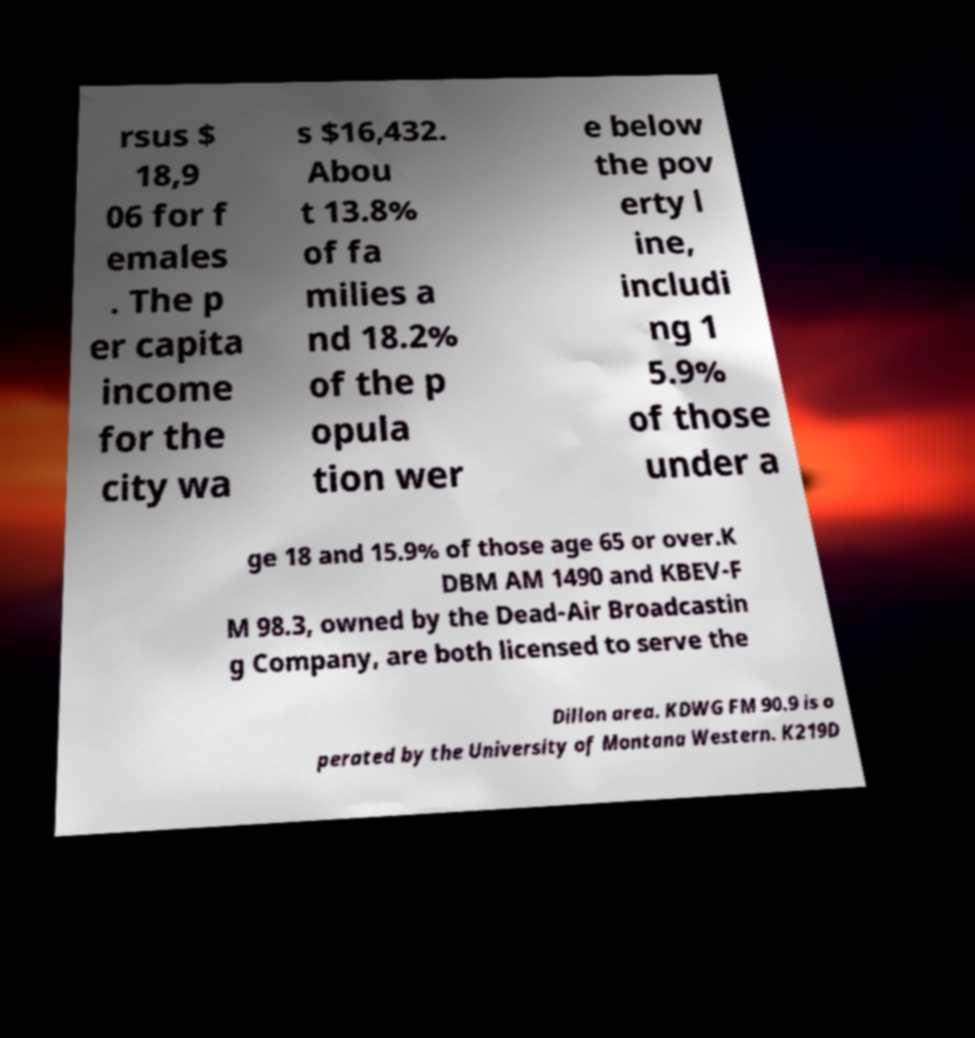Could you assist in decoding the text presented in this image and type it out clearly? rsus $ 18,9 06 for f emales . The p er capita income for the city wa s $16,432. Abou t 13.8% of fa milies a nd 18.2% of the p opula tion wer e below the pov erty l ine, includi ng 1 5.9% of those under a ge 18 and 15.9% of those age 65 or over.K DBM AM 1490 and KBEV-F M 98.3, owned by the Dead-Air Broadcastin g Company, are both licensed to serve the Dillon area. KDWG FM 90.9 is o perated by the University of Montana Western. K219D 